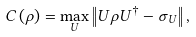<formula> <loc_0><loc_0><loc_500><loc_500>C \left ( \rho \right ) = \max _ { U } \left \| U \rho U ^ { \dag } - \sigma _ { U } \right \| ,</formula> 